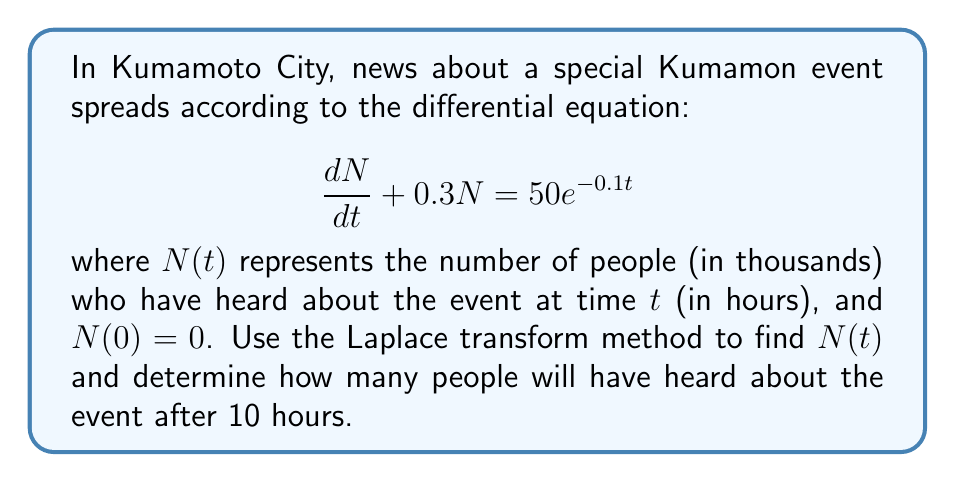Could you help me with this problem? Let's solve this problem step by step using the Laplace transform method:

1) Take the Laplace transform of both sides of the equation:
   $$\mathcal{L}\left\{\frac{dN}{dt} + 0.3N\right\} = \mathcal{L}\{50e^{-0.1t}\}$$

2) Using Laplace transform properties:
   $$sN(s) - N(0) + 0.3N(s) = \frac{50}{s+0.1}$$

3) Given that $N(0) = 0$:
   $$(s + 0.3)N(s) = \frac{50}{s+0.1}$$

4) Solve for $N(s)$:
   $$N(s) = \frac{50}{(s+0.3)(s+0.1)} = \frac{A}{s+0.3} + \frac{B}{s+0.1}$$

5) Find partial fractions:
   $$\frac{50}{(s+0.3)(s+0.1)} = \frac{A}{s+0.3} + \frac{B}{s+0.1}$$
   $$50 = A(s+0.1) + B(s+0.3)$$
   When $s = -0.3$: $50 = B(-0.2)$, so $B = -250$
   When $s = -0.1$: $50 = A(0.2)$, so $A = 250$

6) Therefore:
   $$N(s) = \frac{250}{s+0.3} - \frac{250}{s+0.1}$$

7) Take the inverse Laplace transform:
   $$N(t) = 250e^{-0.3t} - 250e^{-0.1t}$$

8) To find $N(10)$, substitute $t = 10$:
   $$N(10) = 250e^{-0.3(10)} - 250e^{-0.1(10)}$$
   $$N(10) = 250e^{-3} - 250e^{-1}$$
   $$N(10) \approx 12.47 - 91.97 = -79.50$$

Therefore, after 10 hours, approximately 79,500 people will have heard about the event.
Answer: $N(t) = 250e^{-0.3t} - 250e^{-0.1t}$

After 10 hours, approximately 79,500 people will have heard about the event. 